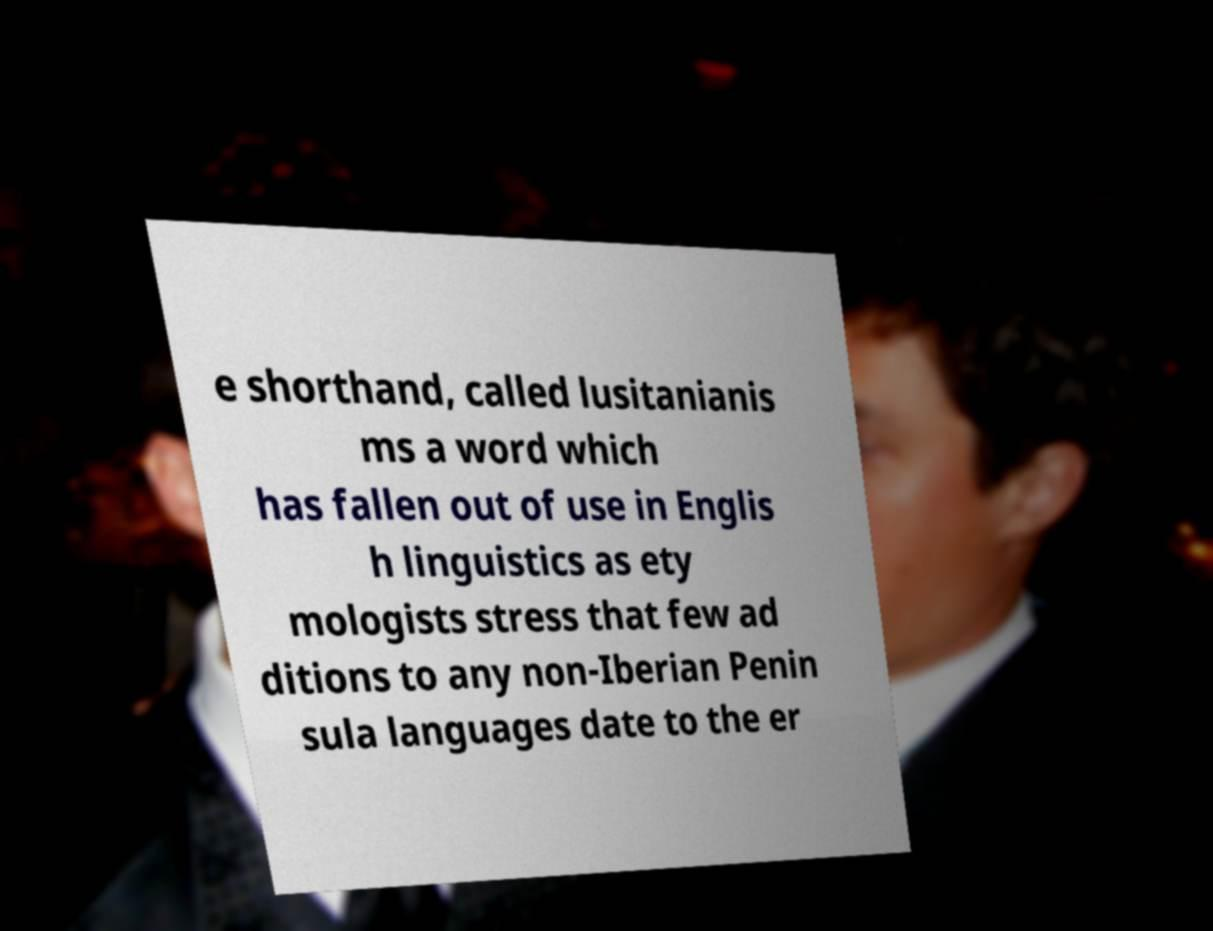Can you read and provide the text displayed in the image?This photo seems to have some interesting text. Can you extract and type it out for me? e shorthand, called lusitanianis ms a word which has fallen out of use in Englis h linguistics as ety mologists stress that few ad ditions to any non-Iberian Penin sula languages date to the er 